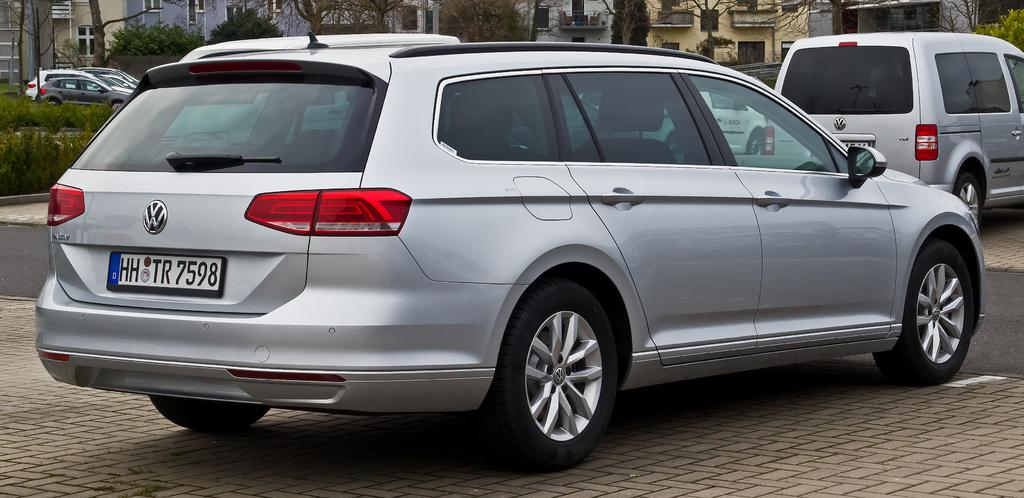What can be seen moving on the roads in the image? There are vehicles on the roads in the image. What type of structures can be seen in the background of the image? There are buildings in the background of the image. What type of natural elements are present in the background of the image? Trees and plants are visible in the background of the image. What other objects can be seen in the background of the image? There are other objects in the background of the image. How many apples are hanging from the trees in the image? There are no apples visible in the image. What type of skirt is being worn by the trees in the image? There are no skirts present in the image. 